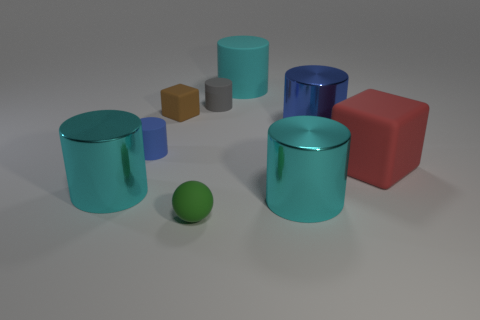How many tiny brown objects have the same material as the sphere?
Your answer should be very brief. 1. Is the size of the green rubber ball that is on the left side of the large blue shiny cylinder the same as the blue object that is to the left of the small brown cube?
Offer a very short reply. Yes. What is the color of the matte thing in front of the large shiny thing to the left of the small rubber cylinder to the left of the tiny gray rubber object?
Your response must be concise. Green. Are there any small shiny things of the same shape as the tiny blue matte thing?
Ensure brevity in your answer.  No. Are there an equal number of small green rubber balls behind the red object and cyan cylinders that are in front of the small gray rubber thing?
Your answer should be compact. No. Do the big cyan thing that is behind the red matte object and the red thing have the same shape?
Ensure brevity in your answer.  No. Do the small blue object and the large blue object have the same shape?
Provide a succinct answer. Yes. How many shiny things are either cyan cylinders or purple cylinders?
Your answer should be compact. 2. Is the blue rubber object the same size as the red object?
Provide a succinct answer. No. How many things are large blue objects or shiny things to the right of the small brown thing?
Offer a very short reply. 2. 